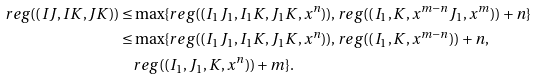<formula> <loc_0><loc_0><loc_500><loc_500>r e g ( ( I J , I K , J K ) ) \leq & \max \{ r e g ( ( I _ { 1 } J _ { 1 } , I _ { 1 } K , J _ { 1 } K , x ^ { n } ) ) , r e g ( ( I _ { 1 } , K , x ^ { m - n } J _ { 1 } , x ^ { m } ) ) + n \} \\ \leq & \max \{ r e g ( ( I _ { 1 } J _ { 1 } , I _ { 1 } K , J _ { 1 } K , x ^ { n } ) ) , r e g ( ( I _ { 1 } , K , x ^ { m - n } ) ) + n , \\ & r e g ( ( I _ { 1 } , J _ { 1 } , K , x ^ { n } ) ) + m \} .</formula> 